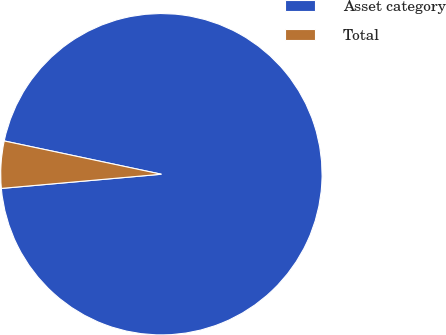Convert chart to OTSL. <chart><loc_0><loc_0><loc_500><loc_500><pie_chart><fcel>Asset category<fcel>Total<nl><fcel>95.27%<fcel>4.73%<nl></chart> 